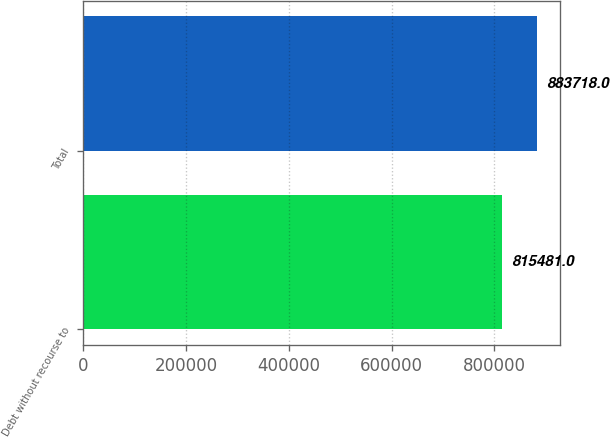Convert chart. <chart><loc_0><loc_0><loc_500><loc_500><bar_chart><fcel>Debt without recourse to<fcel>Total<nl><fcel>815481<fcel>883718<nl></chart> 